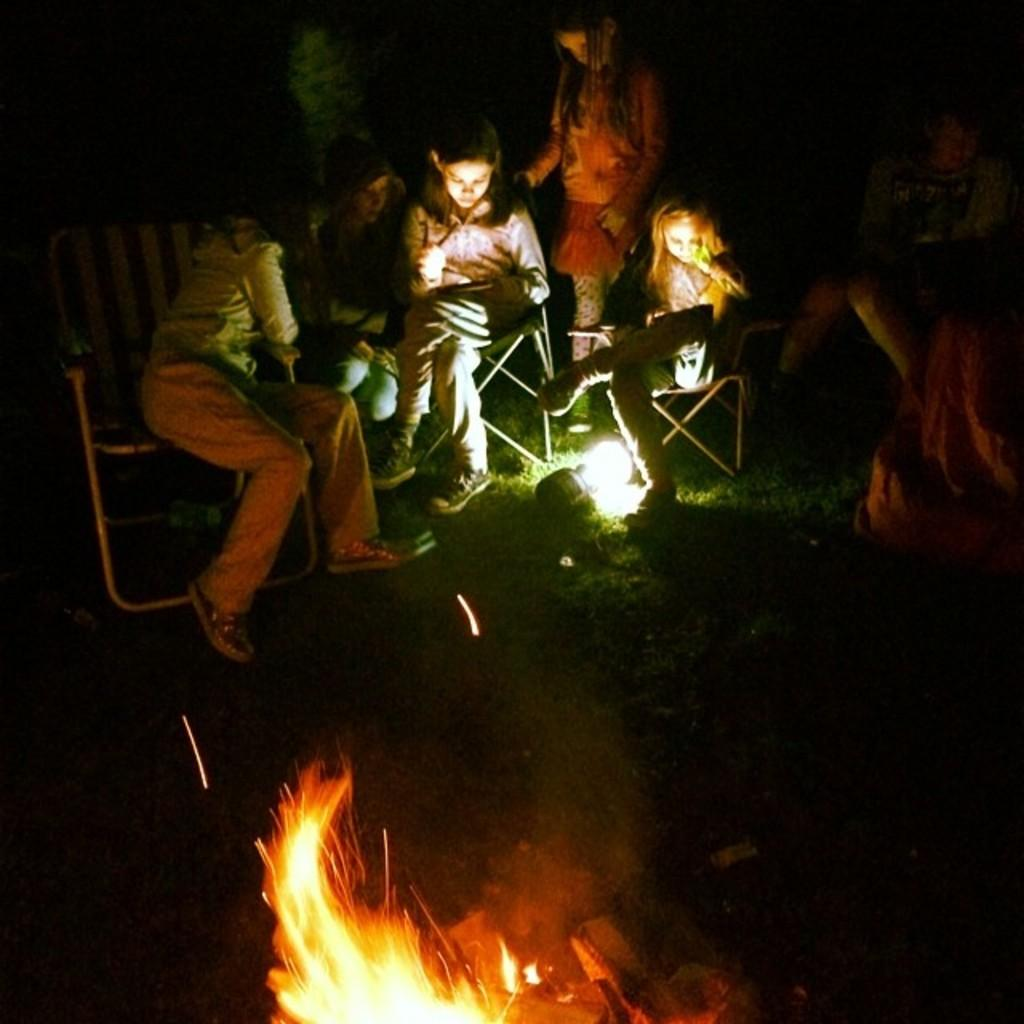What are the people in the image doing? The people in the image are sitting on chairs. Can you describe the position of the person in the image? There is a person standing on a surface in the image. What can be seen in the image that produces heat and light? There is fire visible in the image. What is the source of illumination in the image? There is light visible in the image. What type of curve can be seen in the image? There is no curve present in the image. How many weeks have passed since the event in the image occurred? The image does not provide any information about the time or duration of the event. 